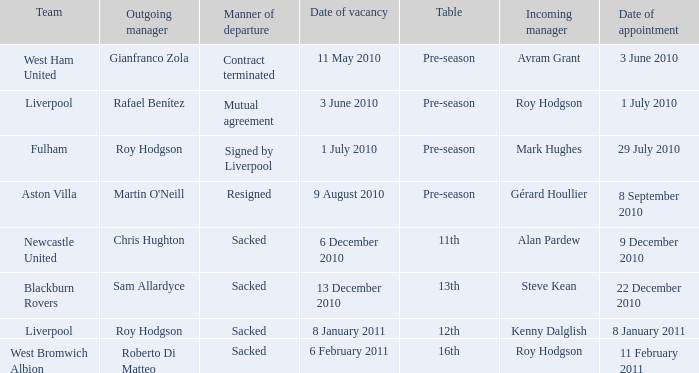What is the ranking for the team blackburn rovers? 13th. 